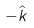Convert formula to latex. <formula><loc_0><loc_0><loc_500><loc_500>- \hat { k }</formula> 